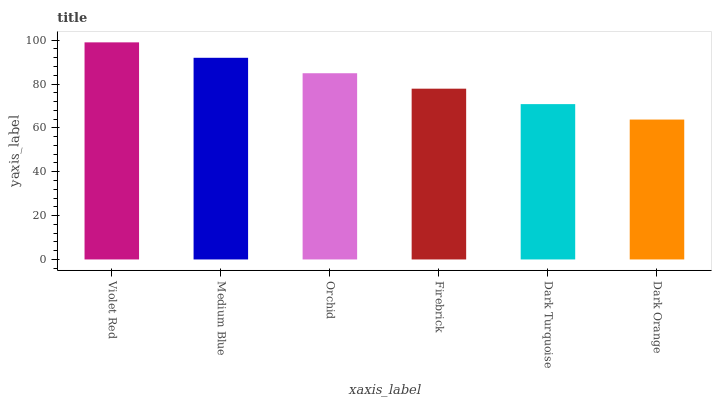Is Dark Orange the minimum?
Answer yes or no. Yes. Is Violet Red the maximum?
Answer yes or no. Yes. Is Medium Blue the minimum?
Answer yes or no. No. Is Medium Blue the maximum?
Answer yes or no. No. Is Violet Red greater than Medium Blue?
Answer yes or no. Yes. Is Medium Blue less than Violet Red?
Answer yes or no. Yes. Is Medium Blue greater than Violet Red?
Answer yes or no. No. Is Violet Red less than Medium Blue?
Answer yes or no. No. Is Orchid the high median?
Answer yes or no. Yes. Is Firebrick the low median?
Answer yes or no. Yes. Is Medium Blue the high median?
Answer yes or no. No. Is Dark Turquoise the low median?
Answer yes or no. No. 